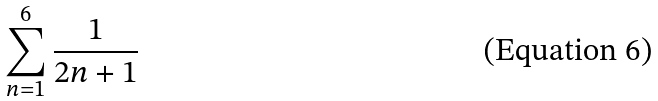Convert formula to latex. <formula><loc_0><loc_0><loc_500><loc_500>\sum _ { n = 1 } ^ { 6 } \frac { 1 } { 2 n + 1 }</formula> 